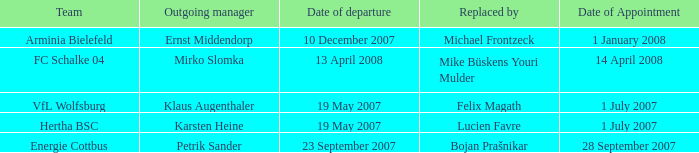When is the appointment date for outgoing manager Petrik Sander? 28 September 2007. Could you parse the entire table as a dict? {'header': ['Team', 'Outgoing manager', 'Date of departure', 'Replaced by', 'Date of Appointment'], 'rows': [['Arminia Bielefeld', 'Ernst Middendorp', '10 December 2007', 'Michael Frontzeck', '1 January 2008'], ['FC Schalke 04', 'Mirko Slomka', '13 April 2008', 'Mike Büskens Youri Mulder', '14 April 2008'], ['VfL Wolfsburg', 'Klaus Augenthaler', '19 May 2007', 'Felix Magath', '1 July 2007'], ['Hertha BSC', 'Karsten Heine', '19 May 2007', 'Lucien Favre', '1 July 2007'], ['Energie Cottbus', 'Petrik Sander', '23 September 2007', 'Bojan Prašnikar', '28 September 2007']]} 